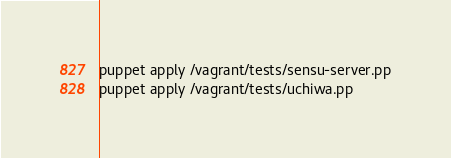<code> <loc_0><loc_0><loc_500><loc_500><_Bash_>puppet apply /vagrant/tests/sensu-server.pp
puppet apply /vagrant/tests/uchiwa.pp
</code> 